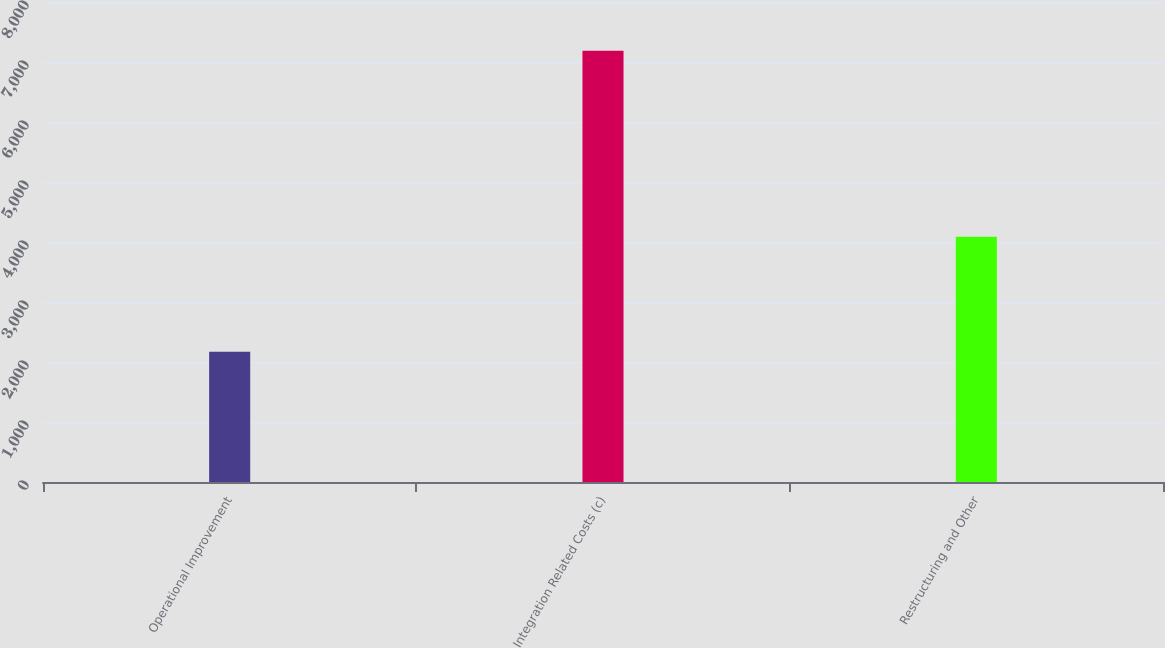Convert chart to OTSL. <chart><loc_0><loc_0><loc_500><loc_500><bar_chart><fcel>Operational Improvement<fcel>Integration Related Costs (c)<fcel>Restructuring and Other<nl><fcel>2169<fcel>7188<fcel>4086<nl></chart> 